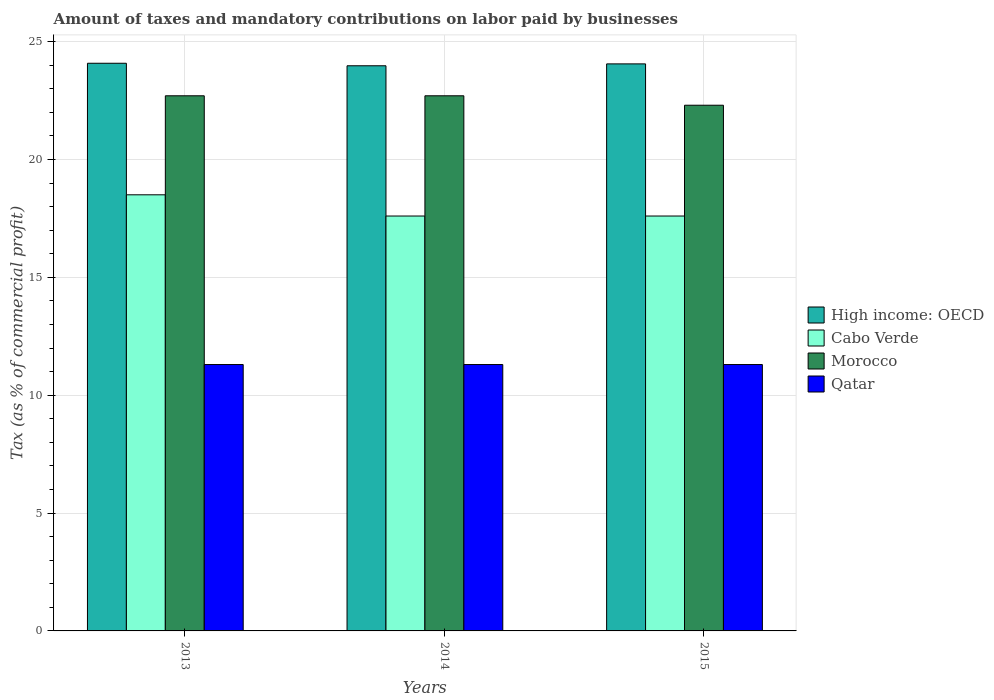How many different coloured bars are there?
Offer a terse response. 4. How many bars are there on the 2nd tick from the left?
Offer a terse response. 4. How many bars are there on the 3rd tick from the right?
Keep it short and to the point. 4. What is the label of the 1st group of bars from the left?
Keep it short and to the point. 2013. In how many cases, is the number of bars for a given year not equal to the number of legend labels?
Offer a terse response. 0. What is the percentage of taxes paid by businesses in High income: OECD in 2013?
Give a very brief answer. 24.08. Across all years, what is the maximum percentage of taxes paid by businesses in High income: OECD?
Make the answer very short. 24.08. In which year was the percentage of taxes paid by businesses in Cabo Verde maximum?
Offer a terse response. 2013. What is the total percentage of taxes paid by businesses in Qatar in the graph?
Offer a very short reply. 33.9. What is the difference between the percentage of taxes paid by businesses in High income: OECD in 2014 and that in 2015?
Make the answer very short. -0.08. What is the difference between the percentage of taxes paid by businesses in High income: OECD in 2015 and the percentage of taxes paid by businesses in Cabo Verde in 2013?
Give a very brief answer. 5.55. What is the average percentage of taxes paid by businesses in High income: OECD per year?
Ensure brevity in your answer.  24.04. In the year 2014, what is the difference between the percentage of taxes paid by businesses in Morocco and percentage of taxes paid by businesses in Qatar?
Your answer should be compact. 11.4. What is the ratio of the percentage of taxes paid by businesses in Morocco in 2014 to that in 2015?
Offer a terse response. 1.02. What is the difference between the highest and the second highest percentage of taxes paid by businesses in Cabo Verde?
Your answer should be very brief. 0.9. What is the difference between the highest and the lowest percentage of taxes paid by businesses in Cabo Verde?
Provide a short and direct response. 0.9. Is it the case that in every year, the sum of the percentage of taxes paid by businesses in Cabo Verde and percentage of taxes paid by businesses in Morocco is greater than the sum of percentage of taxes paid by businesses in High income: OECD and percentage of taxes paid by businesses in Qatar?
Give a very brief answer. Yes. What does the 3rd bar from the left in 2015 represents?
Provide a short and direct response. Morocco. What does the 1st bar from the right in 2013 represents?
Give a very brief answer. Qatar. Is it the case that in every year, the sum of the percentage of taxes paid by businesses in Qatar and percentage of taxes paid by businesses in Cabo Verde is greater than the percentage of taxes paid by businesses in High income: OECD?
Your answer should be very brief. Yes. Are all the bars in the graph horizontal?
Provide a succinct answer. No. How many years are there in the graph?
Keep it short and to the point. 3. What is the difference between two consecutive major ticks on the Y-axis?
Keep it short and to the point. 5. How are the legend labels stacked?
Ensure brevity in your answer.  Vertical. What is the title of the graph?
Provide a succinct answer. Amount of taxes and mandatory contributions on labor paid by businesses. Does "Uruguay" appear as one of the legend labels in the graph?
Your answer should be very brief. No. What is the label or title of the X-axis?
Give a very brief answer. Years. What is the label or title of the Y-axis?
Make the answer very short. Tax (as % of commercial profit). What is the Tax (as % of commercial profit) of High income: OECD in 2013?
Provide a succinct answer. 24.08. What is the Tax (as % of commercial profit) of Cabo Verde in 2013?
Provide a succinct answer. 18.5. What is the Tax (as % of commercial profit) of Morocco in 2013?
Your response must be concise. 22.7. What is the Tax (as % of commercial profit) in High income: OECD in 2014?
Keep it short and to the point. 23.97. What is the Tax (as % of commercial profit) in Morocco in 2014?
Provide a short and direct response. 22.7. What is the Tax (as % of commercial profit) in High income: OECD in 2015?
Make the answer very short. 24.05. What is the Tax (as % of commercial profit) in Cabo Verde in 2015?
Your response must be concise. 17.6. What is the Tax (as % of commercial profit) in Morocco in 2015?
Provide a short and direct response. 22.3. What is the Tax (as % of commercial profit) of Qatar in 2015?
Your answer should be compact. 11.3. Across all years, what is the maximum Tax (as % of commercial profit) of High income: OECD?
Your answer should be very brief. 24.08. Across all years, what is the maximum Tax (as % of commercial profit) in Cabo Verde?
Keep it short and to the point. 18.5. Across all years, what is the maximum Tax (as % of commercial profit) of Morocco?
Offer a terse response. 22.7. Across all years, what is the minimum Tax (as % of commercial profit) in High income: OECD?
Keep it short and to the point. 23.97. Across all years, what is the minimum Tax (as % of commercial profit) of Morocco?
Provide a succinct answer. 22.3. What is the total Tax (as % of commercial profit) of High income: OECD in the graph?
Keep it short and to the point. 72.11. What is the total Tax (as % of commercial profit) in Cabo Verde in the graph?
Ensure brevity in your answer.  53.7. What is the total Tax (as % of commercial profit) in Morocco in the graph?
Make the answer very short. 67.7. What is the total Tax (as % of commercial profit) in Qatar in the graph?
Your answer should be compact. 33.9. What is the difference between the Tax (as % of commercial profit) in High income: OECD in 2013 and that in 2014?
Provide a short and direct response. 0.11. What is the difference between the Tax (as % of commercial profit) of Morocco in 2013 and that in 2014?
Your answer should be very brief. 0. What is the difference between the Tax (as % of commercial profit) of Qatar in 2013 and that in 2014?
Provide a short and direct response. 0. What is the difference between the Tax (as % of commercial profit) of High income: OECD in 2013 and that in 2015?
Your answer should be very brief. 0.03. What is the difference between the Tax (as % of commercial profit) of Morocco in 2013 and that in 2015?
Offer a very short reply. 0.4. What is the difference between the Tax (as % of commercial profit) of High income: OECD in 2014 and that in 2015?
Your answer should be very brief. -0.08. What is the difference between the Tax (as % of commercial profit) of Morocco in 2014 and that in 2015?
Ensure brevity in your answer.  0.4. What is the difference between the Tax (as % of commercial profit) in Qatar in 2014 and that in 2015?
Provide a succinct answer. 0. What is the difference between the Tax (as % of commercial profit) of High income: OECD in 2013 and the Tax (as % of commercial profit) of Cabo Verde in 2014?
Your response must be concise. 6.48. What is the difference between the Tax (as % of commercial profit) in High income: OECD in 2013 and the Tax (as % of commercial profit) in Morocco in 2014?
Offer a terse response. 1.38. What is the difference between the Tax (as % of commercial profit) in High income: OECD in 2013 and the Tax (as % of commercial profit) in Qatar in 2014?
Keep it short and to the point. 12.78. What is the difference between the Tax (as % of commercial profit) of Cabo Verde in 2013 and the Tax (as % of commercial profit) of Morocco in 2014?
Make the answer very short. -4.2. What is the difference between the Tax (as % of commercial profit) in Morocco in 2013 and the Tax (as % of commercial profit) in Qatar in 2014?
Ensure brevity in your answer.  11.4. What is the difference between the Tax (as % of commercial profit) of High income: OECD in 2013 and the Tax (as % of commercial profit) of Cabo Verde in 2015?
Offer a terse response. 6.48. What is the difference between the Tax (as % of commercial profit) in High income: OECD in 2013 and the Tax (as % of commercial profit) in Morocco in 2015?
Your answer should be compact. 1.78. What is the difference between the Tax (as % of commercial profit) of High income: OECD in 2013 and the Tax (as % of commercial profit) of Qatar in 2015?
Provide a succinct answer. 12.78. What is the difference between the Tax (as % of commercial profit) in Cabo Verde in 2013 and the Tax (as % of commercial profit) in Morocco in 2015?
Offer a terse response. -3.8. What is the difference between the Tax (as % of commercial profit) of Cabo Verde in 2013 and the Tax (as % of commercial profit) of Qatar in 2015?
Your answer should be compact. 7.2. What is the difference between the Tax (as % of commercial profit) in Morocco in 2013 and the Tax (as % of commercial profit) in Qatar in 2015?
Your answer should be very brief. 11.4. What is the difference between the Tax (as % of commercial profit) in High income: OECD in 2014 and the Tax (as % of commercial profit) in Cabo Verde in 2015?
Give a very brief answer. 6.37. What is the difference between the Tax (as % of commercial profit) in High income: OECD in 2014 and the Tax (as % of commercial profit) in Morocco in 2015?
Keep it short and to the point. 1.67. What is the difference between the Tax (as % of commercial profit) in High income: OECD in 2014 and the Tax (as % of commercial profit) in Qatar in 2015?
Offer a terse response. 12.67. What is the difference between the Tax (as % of commercial profit) in Cabo Verde in 2014 and the Tax (as % of commercial profit) in Morocco in 2015?
Your response must be concise. -4.7. What is the difference between the Tax (as % of commercial profit) of Cabo Verde in 2014 and the Tax (as % of commercial profit) of Qatar in 2015?
Give a very brief answer. 6.3. What is the average Tax (as % of commercial profit) of High income: OECD per year?
Offer a terse response. 24.04. What is the average Tax (as % of commercial profit) in Morocco per year?
Your response must be concise. 22.57. What is the average Tax (as % of commercial profit) in Qatar per year?
Ensure brevity in your answer.  11.3. In the year 2013, what is the difference between the Tax (as % of commercial profit) of High income: OECD and Tax (as % of commercial profit) of Cabo Verde?
Your answer should be very brief. 5.58. In the year 2013, what is the difference between the Tax (as % of commercial profit) in High income: OECD and Tax (as % of commercial profit) in Morocco?
Give a very brief answer. 1.38. In the year 2013, what is the difference between the Tax (as % of commercial profit) of High income: OECD and Tax (as % of commercial profit) of Qatar?
Offer a very short reply. 12.78. In the year 2014, what is the difference between the Tax (as % of commercial profit) of High income: OECD and Tax (as % of commercial profit) of Cabo Verde?
Offer a terse response. 6.37. In the year 2014, what is the difference between the Tax (as % of commercial profit) in High income: OECD and Tax (as % of commercial profit) in Morocco?
Your answer should be very brief. 1.27. In the year 2014, what is the difference between the Tax (as % of commercial profit) of High income: OECD and Tax (as % of commercial profit) of Qatar?
Offer a terse response. 12.67. In the year 2014, what is the difference between the Tax (as % of commercial profit) of Cabo Verde and Tax (as % of commercial profit) of Morocco?
Provide a succinct answer. -5.1. In the year 2015, what is the difference between the Tax (as % of commercial profit) in High income: OECD and Tax (as % of commercial profit) in Cabo Verde?
Provide a succinct answer. 6.45. In the year 2015, what is the difference between the Tax (as % of commercial profit) in High income: OECD and Tax (as % of commercial profit) in Morocco?
Make the answer very short. 1.75. In the year 2015, what is the difference between the Tax (as % of commercial profit) in High income: OECD and Tax (as % of commercial profit) in Qatar?
Your response must be concise. 12.75. In the year 2015, what is the difference between the Tax (as % of commercial profit) in Cabo Verde and Tax (as % of commercial profit) in Morocco?
Ensure brevity in your answer.  -4.7. In the year 2015, what is the difference between the Tax (as % of commercial profit) in Morocco and Tax (as % of commercial profit) in Qatar?
Offer a very short reply. 11. What is the ratio of the Tax (as % of commercial profit) in Cabo Verde in 2013 to that in 2014?
Provide a short and direct response. 1.05. What is the ratio of the Tax (as % of commercial profit) of Morocco in 2013 to that in 2014?
Provide a short and direct response. 1. What is the ratio of the Tax (as % of commercial profit) of Qatar in 2013 to that in 2014?
Your answer should be compact. 1. What is the ratio of the Tax (as % of commercial profit) of High income: OECD in 2013 to that in 2015?
Offer a terse response. 1. What is the ratio of the Tax (as % of commercial profit) of Cabo Verde in 2013 to that in 2015?
Provide a succinct answer. 1.05. What is the ratio of the Tax (as % of commercial profit) in Morocco in 2013 to that in 2015?
Offer a very short reply. 1.02. What is the ratio of the Tax (as % of commercial profit) in Qatar in 2013 to that in 2015?
Make the answer very short. 1. What is the ratio of the Tax (as % of commercial profit) of High income: OECD in 2014 to that in 2015?
Your response must be concise. 1. What is the ratio of the Tax (as % of commercial profit) of Morocco in 2014 to that in 2015?
Give a very brief answer. 1.02. What is the ratio of the Tax (as % of commercial profit) of Qatar in 2014 to that in 2015?
Your answer should be very brief. 1. What is the difference between the highest and the second highest Tax (as % of commercial profit) in High income: OECD?
Offer a terse response. 0.03. What is the difference between the highest and the second highest Tax (as % of commercial profit) in Cabo Verde?
Offer a very short reply. 0.9. What is the difference between the highest and the second highest Tax (as % of commercial profit) of Qatar?
Give a very brief answer. 0. What is the difference between the highest and the lowest Tax (as % of commercial profit) in High income: OECD?
Your answer should be very brief. 0.11. 